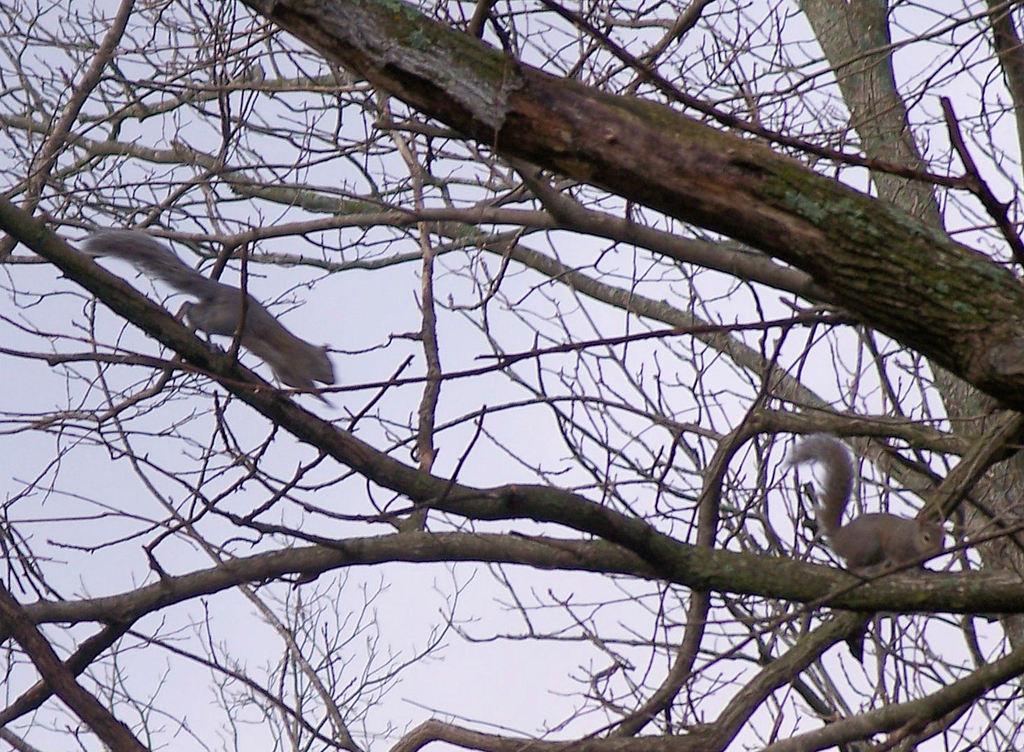Please provide a concise description of this image. In this image we can see two squirrels on the branches of a tree. Behind the tree we can see the sky. 